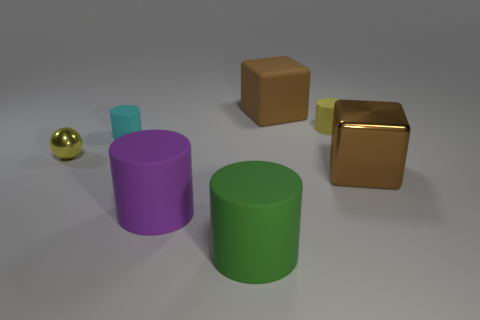Subtract all brown cubes. How many were subtracted if there are1brown cubes left? 1 Add 3 cyan matte things. How many objects exist? 10 Subtract all balls. How many objects are left? 6 Add 5 tiny cyan metal blocks. How many tiny cyan metal blocks exist? 5 Subtract 0 yellow blocks. How many objects are left? 7 Subtract all large rubber cylinders. Subtract all brown cubes. How many objects are left? 3 Add 6 small yellow rubber cylinders. How many small yellow rubber cylinders are left? 7 